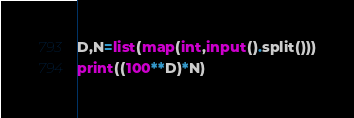<code> <loc_0><loc_0><loc_500><loc_500><_Python_>D,N=list(map(int,input().split()))
print((100**D)*N)</code> 